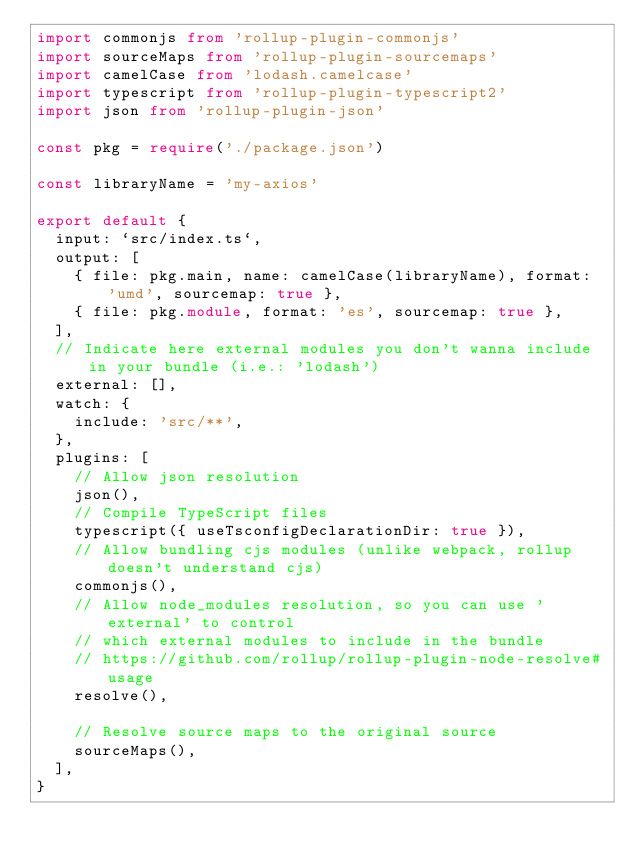<code> <loc_0><loc_0><loc_500><loc_500><_TypeScript_>import commonjs from 'rollup-plugin-commonjs'
import sourceMaps from 'rollup-plugin-sourcemaps'
import camelCase from 'lodash.camelcase'
import typescript from 'rollup-plugin-typescript2'
import json from 'rollup-plugin-json'

const pkg = require('./package.json')

const libraryName = 'my-axios'

export default {
  input: `src/index.ts`,
  output: [
    { file: pkg.main, name: camelCase(libraryName), format: 'umd', sourcemap: true },
    { file: pkg.module, format: 'es', sourcemap: true },
  ],
  // Indicate here external modules you don't wanna include in your bundle (i.e.: 'lodash')
  external: [],
  watch: {
    include: 'src/**',
  },
  plugins: [
    // Allow json resolution
    json(),
    // Compile TypeScript files
    typescript({ useTsconfigDeclarationDir: true }),
    // Allow bundling cjs modules (unlike webpack, rollup doesn't understand cjs)
    commonjs(),
    // Allow node_modules resolution, so you can use 'external' to control
    // which external modules to include in the bundle
    // https://github.com/rollup/rollup-plugin-node-resolve#usage
    resolve(),

    // Resolve source maps to the original source
    sourceMaps(),
  ],
}
</code> 